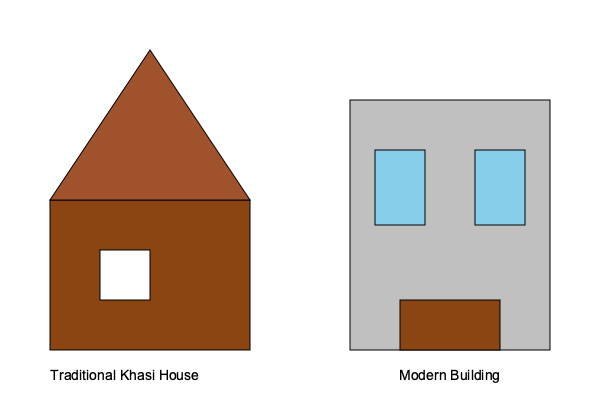Compare the architectural styles of traditional Khasi houses and modern buildings, focusing on their structural elements, materials used, and cultural significance. How do these differences reflect changes in Khasi society and the challenges faced in preserving traditional architecture? 1. Structural Elements:
   - Traditional Khasi house:
     a) Triangular roof structure (gable roof)
     b) Single-story design
     c) Smaller windows and doors
   - Modern building:
     a) Flat or slightly sloped roof
     b) Multi-story design
     c) Larger windows and doors

2. Materials Used:
   - Traditional Khasi house:
     a) Wood (primary material)
     b) Thatch or bamboo (roofing)
     c) Natural, locally sourced materials
   - Modern building:
     a) Concrete and steel (primary materials)
     b) Glass (for windows)
     c) Manufactured and imported materials

3. Cultural Significance:
   - Traditional Khasi house:
     a) Reflects harmony with nature
     b) Incorporates traditional beliefs and customs
     c) Designed for extended family living
   - Modern building:
     a) Prioritizes functionality and space efficiency
     b) Reflects contemporary lifestyle needs
     c) Often designed for nuclear families or commercial use

4. Changes in Khasi Society:
   a) Urbanization and population growth
   b) Influence of global architectural trends
   c) Changing family structures and lifestyles
   d) Economic development and increased access to modern materials

5. Challenges in Preserving Traditional Architecture:
   a) Scarcity of traditional building materials
   b) Loss of traditional building skills and knowledge
   c) Land scarcity and pressure for vertical development
   d) Building regulations and safety standards favoring modern construction

6. Preservation Efforts:
   a) Documentation of traditional building techniques
   b) Incorporation of traditional elements in modern designs
   c) Cultural heritage preservation initiatives
   d) Promotion of sustainable and eco-friendly building practices inspired by traditional wisdom

The differences between traditional Khasi houses and modern buildings reflect the ongoing tension between cultural preservation and modernization. While modern buildings offer practical advantages in terms of space utilization and durability, they often lack the cultural significance and environmental harmony of traditional Khasi architecture. The challenge lies in finding a balance that respects cultural heritage while meeting contemporary needs and standards.
Answer: Traditional Khasi houses reflect cultural harmony with nature using local materials, while modern buildings prioritize functionality with contemporary materials, highlighting the challenge of balancing cultural preservation with modernization in Khasi society. 